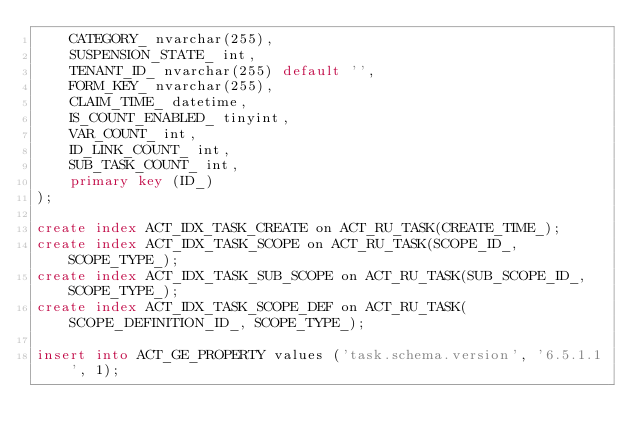Convert code to text. <code><loc_0><loc_0><loc_500><loc_500><_SQL_>    CATEGORY_ nvarchar(255),
    SUSPENSION_STATE_ int,
    TENANT_ID_ nvarchar(255) default '',
    FORM_KEY_ nvarchar(255),
    CLAIM_TIME_ datetime,
    IS_COUNT_ENABLED_ tinyint,
    VAR_COUNT_ int, 
    ID_LINK_COUNT_ int,
    SUB_TASK_COUNT_ int,
    primary key (ID_)
);

create index ACT_IDX_TASK_CREATE on ACT_RU_TASK(CREATE_TIME_);
create index ACT_IDX_TASK_SCOPE on ACT_RU_TASK(SCOPE_ID_, SCOPE_TYPE_);
create index ACT_IDX_TASK_SUB_SCOPE on ACT_RU_TASK(SUB_SCOPE_ID_, SCOPE_TYPE_);
create index ACT_IDX_TASK_SCOPE_DEF on ACT_RU_TASK(SCOPE_DEFINITION_ID_, SCOPE_TYPE_);

insert into ACT_GE_PROPERTY values ('task.schema.version', '6.5.1.1', 1);</code> 